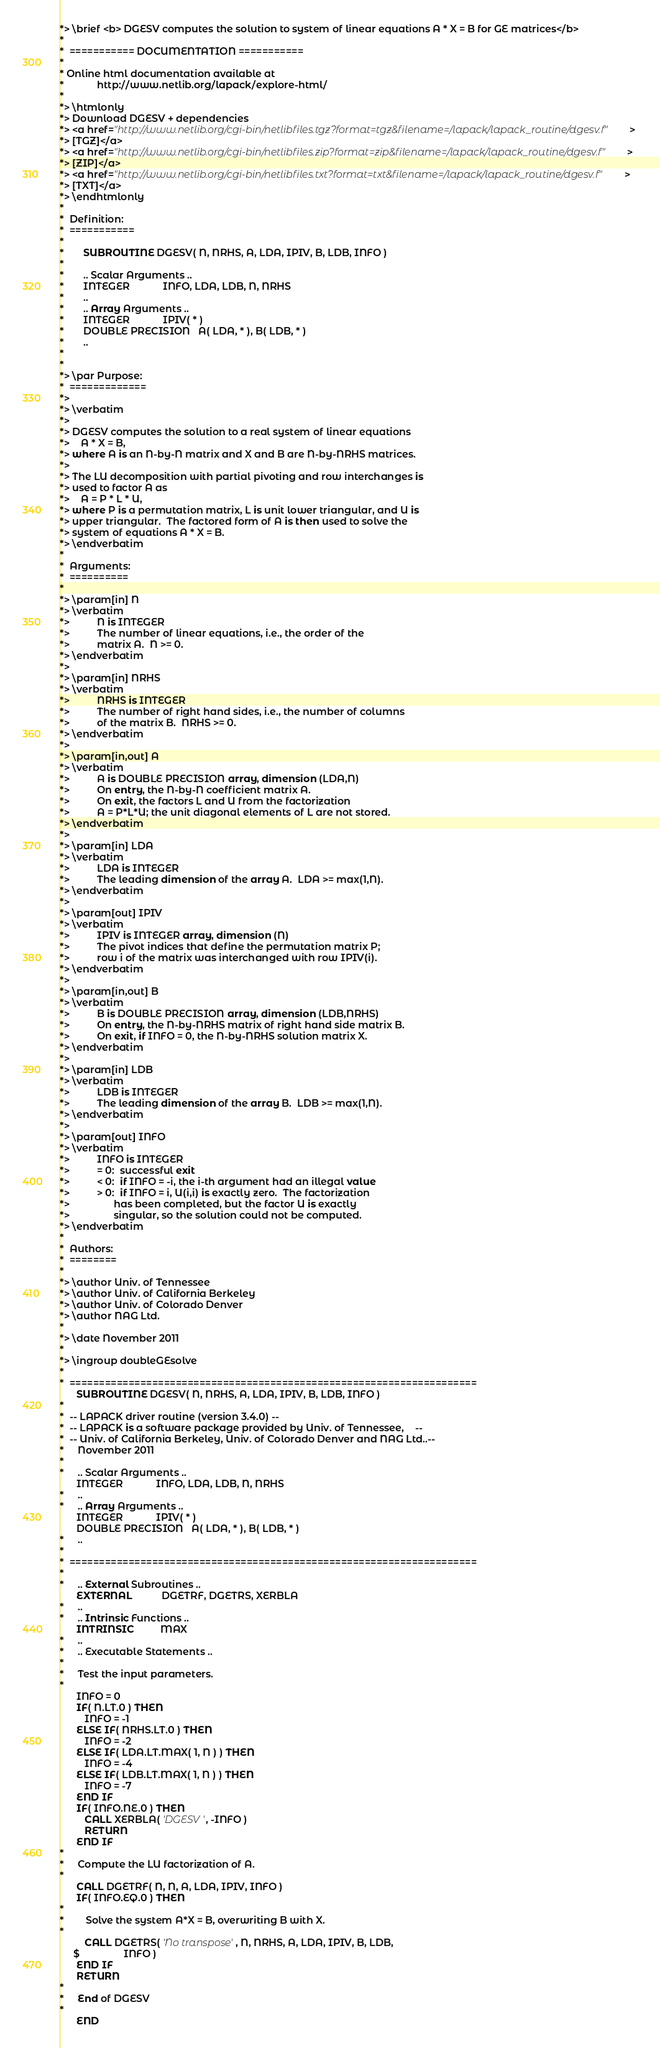<code> <loc_0><loc_0><loc_500><loc_500><_FORTRAN_>*> \brief <b> DGESV computes the solution to system of linear equations A * X = B for GE matrices</b>
*
*  =========== DOCUMENTATION ===========
*
* Online html documentation available at 
*            http://www.netlib.org/lapack/explore-html/ 
*
*> \htmlonly
*> Download DGESV + dependencies 
*> <a href="http://www.netlib.org/cgi-bin/netlibfiles.tgz?format=tgz&filename=/lapack/lapack_routine/dgesv.f"> 
*> [TGZ]</a> 
*> <a href="http://www.netlib.org/cgi-bin/netlibfiles.zip?format=zip&filename=/lapack/lapack_routine/dgesv.f"> 
*> [ZIP]</a> 
*> <a href="http://www.netlib.org/cgi-bin/netlibfiles.txt?format=txt&filename=/lapack/lapack_routine/dgesv.f"> 
*> [TXT]</a>
*> \endhtmlonly
*
*  Definition:
*  ===========
*
*       SUBROUTINE DGESV( N, NRHS, A, LDA, IPIV, B, LDB, INFO )
* 
*       .. Scalar Arguments ..
*       INTEGER            INFO, LDA, LDB, N, NRHS
*       ..
*       .. Array Arguments ..
*       INTEGER            IPIV( * )
*       DOUBLE PRECISION   A( LDA, * ), B( LDB, * )
*       ..
*  
*
*> \par Purpose:
*  =============
*>
*> \verbatim
*>
*> DGESV computes the solution to a real system of linear equations
*>    A * X = B,
*> where A is an N-by-N matrix and X and B are N-by-NRHS matrices.
*>
*> The LU decomposition with partial pivoting and row interchanges is
*> used to factor A as
*>    A = P * L * U,
*> where P is a permutation matrix, L is unit lower triangular, and U is
*> upper triangular.  The factored form of A is then used to solve the
*> system of equations A * X = B.
*> \endverbatim
*
*  Arguments:
*  ==========
*
*> \param[in] N
*> \verbatim
*>          N is INTEGER
*>          The number of linear equations, i.e., the order of the
*>          matrix A.  N >= 0.
*> \endverbatim
*>
*> \param[in] NRHS
*> \verbatim
*>          NRHS is INTEGER
*>          The number of right hand sides, i.e., the number of columns
*>          of the matrix B.  NRHS >= 0.
*> \endverbatim
*>
*> \param[in,out] A
*> \verbatim
*>          A is DOUBLE PRECISION array, dimension (LDA,N)
*>          On entry, the N-by-N coefficient matrix A.
*>          On exit, the factors L and U from the factorization
*>          A = P*L*U; the unit diagonal elements of L are not stored.
*> \endverbatim
*>
*> \param[in] LDA
*> \verbatim
*>          LDA is INTEGER
*>          The leading dimension of the array A.  LDA >= max(1,N).
*> \endverbatim
*>
*> \param[out] IPIV
*> \verbatim
*>          IPIV is INTEGER array, dimension (N)
*>          The pivot indices that define the permutation matrix P;
*>          row i of the matrix was interchanged with row IPIV(i).
*> \endverbatim
*>
*> \param[in,out] B
*> \verbatim
*>          B is DOUBLE PRECISION array, dimension (LDB,NRHS)
*>          On entry, the N-by-NRHS matrix of right hand side matrix B.
*>          On exit, if INFO = 0, the N-by-NRHS solution matrix X.
*> \endverbatim
*>
*> \param[in] LDB
*> \verbatim
*>          LDB is INTEGER
*>          The leading dimension of the array B.  LDB >= max(1,N).
*> \endverbatim
*>
*> \param[out] INFO
*> \verbatim
*>          INFO is INTEGER
*>          = 0:  successful exit
*>          < 0:  if INFO = -i, the i-th argument had an illegal value
*>          > 0:  if INFO = i, U(i,i) is exactly zero.  The factorization
*>                has been completed, but the factor U is exactly
*>                singular, so the solution could not be computed.
*> \endverbatim
*
*  Authors:
*  ========
*
*> \author Univ. of Tennessee 
*> \author Univ. of California Berkeley 
*> \author Univ. of Colorado Denver 
*> \author NAG Ltd. 
*
*> \date November 2011
*
*> \ingroup doubleGEsolve
*
*  =====================================================================
      SUBROUTINE DGESV( N, NRHS, A, LDA, IPIV, B, LDB, INFO )
*
*  -- LAPACK driver routine (version 3.4.0) --
*  -- LAPACK is a software package provided by Univ. of Tennessee,    --
*  -- Univ. of California Berkeley, Univ. of Colorado Denver and NAG Ltd..--
*     November 2011
*
*     .. Scalar Arguments ..
      INTEGER            INFO, LDA, LDB, N, NRHS
*     ..
*     .. Array Arguments ..
      INTEGER            IPIV( * )
      DOUBLE PRECISION   A( LDA, * ), B( LDB, * )
*     ..
*
*  =====================================================================
*
*     .. External Subroutines ..
      EXTERNAL           DGETRF, DGETRS, XERBLA
*     ..
*     .. Intrinsic Functions ..
      INTRINSIC          MAX
*     ..
*     .. Executable Statements ..
*
*     Test the input parameters.
*
      INFO = 0
      IF( N.LT.0 ) THEN
         INFO = -1
      ELSE IF( NRHS.LT.0 ) THEN
         INFO = -2
      ELSE IF( LDA.LT.MAX( 1, N ) ) THEN
         INFO = -4
      ELSE IF( LDB.LT.MAX( 1, N ) ) THEN
         INFO = -7
      END IF
      IF( INFO.NE.0 ) THEN
         CALL XERBLA( 'DGESV ', -INFO )
         RETURN
      END IF
*
*     Compute the LU factorization of A.
*
      CALL DGETRF( N, N, A, LDA, IPIV, INFO )
      IF( INFO.EQ.0 ) THEN
*
*        Solve the system A*X = B, overwriting B with X.
*
         CALL DGETRS( 'No transpose', N, NRHS, A, LDA, IPIV, B, LDB,
     $                INFO )
      END IF
      RETURN
*
*     End of DGESV
*
      END
</code> 